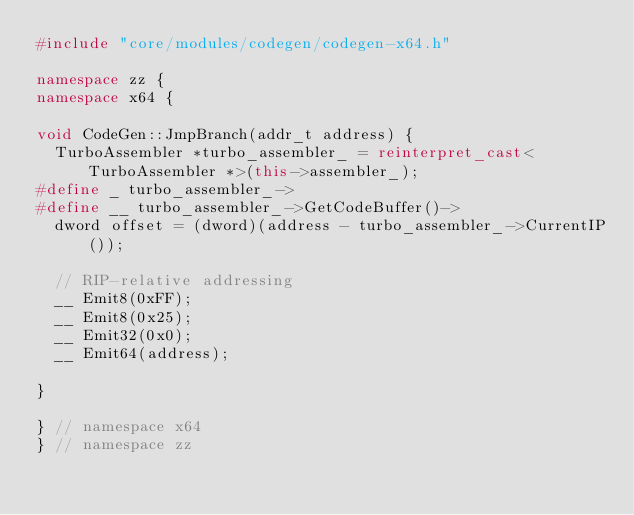Convert code to text. <code><loc_0><loc_0><loc_500><loc_500><_C++_>#include "core/modules/codegen/codegen-x64.h"

namespace zz {
namespace x64 {

void CodeGen::JmpBranch(addr_t address) {
  TurboAssembler *turbo_assembler_ = reinterpret_cast<TurboAssembler *>(this->assembler_);
#define _ turbo_assembler_->
#define __ turbo_assembler_->GetCodeBuffer()->
  dword offset = (dword)(address - turbo_assembler_->CurrentIP());
  
  // RIP-relative addressing
  __ Emit8(0xFF);
  __ Emit8(0x25);
  __ Emit32(0x0);
  __ Emit64(address);
  
}

} // namespace x64
} // namespace zz
</code> 